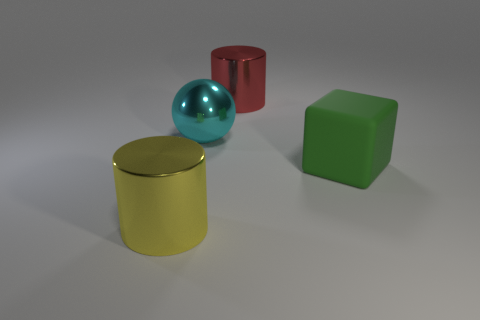There is a big yellow metal object that is to the left of the metallic object behind the big sphere; how many green objects are in front of it?
Provide a succinct answer. 0. The big object that is on the right side of the yellow shiny cylinder and in front of the large cyan shiny thing is made of what material?
Provide a succinct answer. Rubber. Do the big cyan thing and the large cylinder to the right of the large cyan thing have the same material?
Make the answer very short. Yes. Is the number of cyan balls on the left side of the cyan metal ball greater than the number of green blocks behind the red shiny object?
Your answer should be very brief. No. What is the shape of the big rubber object?
Ensure brevity in your answer.  Cube. Is the large cylinder on the right side of the large cyan thing made of the same material as the thing on the left side of the big metallic sphere?
Your answer should be very brief. Yes. What is the shape of the yellow metal object that is left of the large red object?
Your response must be concise. Cylinder. The yellow object that is the same shape as the red thing is what size?
Offer a very short reply. Large. Is the color of the big shiny sphere the same as the big matte thing?
Make the answer very short. No. Is there any other thing that has the same shape as the green matte object?
Offer a terse response. No. 